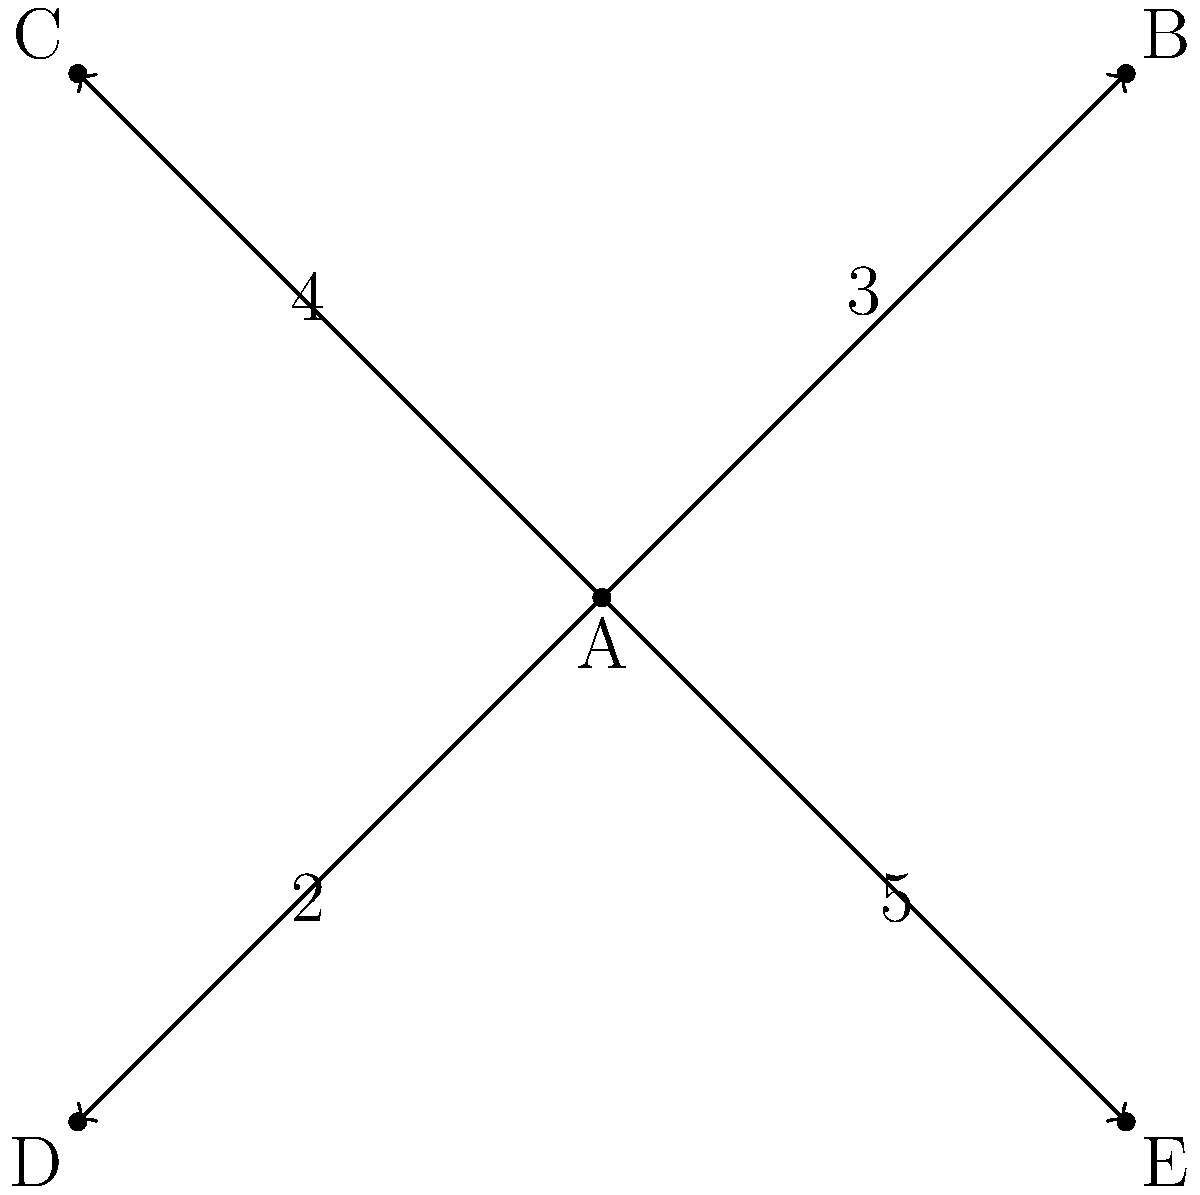As a team leader, you need to distribute tasks among your team members. The weighted graph represents the workload distribution, where vertex A is you, and vertices B, C, D, and E represent your team members. The edge weights indicate the number of tasks assigned to each team member. What is the total number of tasks currently assigned, and how many more tasks can you assign to achieve a balanced workload of 5 tasks per team member? To solve this problem, we'll follow these steps:

1. Calculate the total number of tasks currently assigned:
   - Tasks assigned to B: 3
   - Tasks assigned to C: 4
   - Tasks assigned to D: 2
   - Tasks assigned to E: 5
   Total tasks = $3 + 4 + 2 + 5 = 14$

2. Calculate the ideal balanced workload:
   - Number of team members: 4
   - Desired tasks per member: 5
   Ideal total tasks = $4 \times 5 = 20$

3. Calculate the difference between ideal and current workload:
   Difference = Ideal total tasks - Current total tasks
               = $20 - 14 = 6$

Therefore, the total number of tasks currently assigned is 14, and you need to assign 6 more tasks to achieve a balanced workload of 5 tasks per team member.
Answer: 14 tasks assigned; 6 more tasks needed 